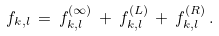Convert formula to latex. <formula><loc_0><loc_0><loc_500><loc_500>f _ { k , l } \, = \, f _ { k , l } ^ { ( \infty ) } \, + \, f _ { k , l } ^ { ( L ) } \, + \, f _ { k , l } ^ { ( R ) } \, .</formula> 